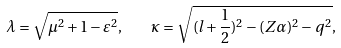<formula> <loc_0><loc_0><loc_500><loc_500>\lambda = \sqrt { \mu ^ { 2 } + 1 - \varepsilon ^ { 2 } } , \quad \kappa = \sqrt { ( l + \frac { 1 } { 2 } ) ^ { 2 } - ( Z \alpha ) ^ { 2 } - q ^ { 2 } } ,</formula> 